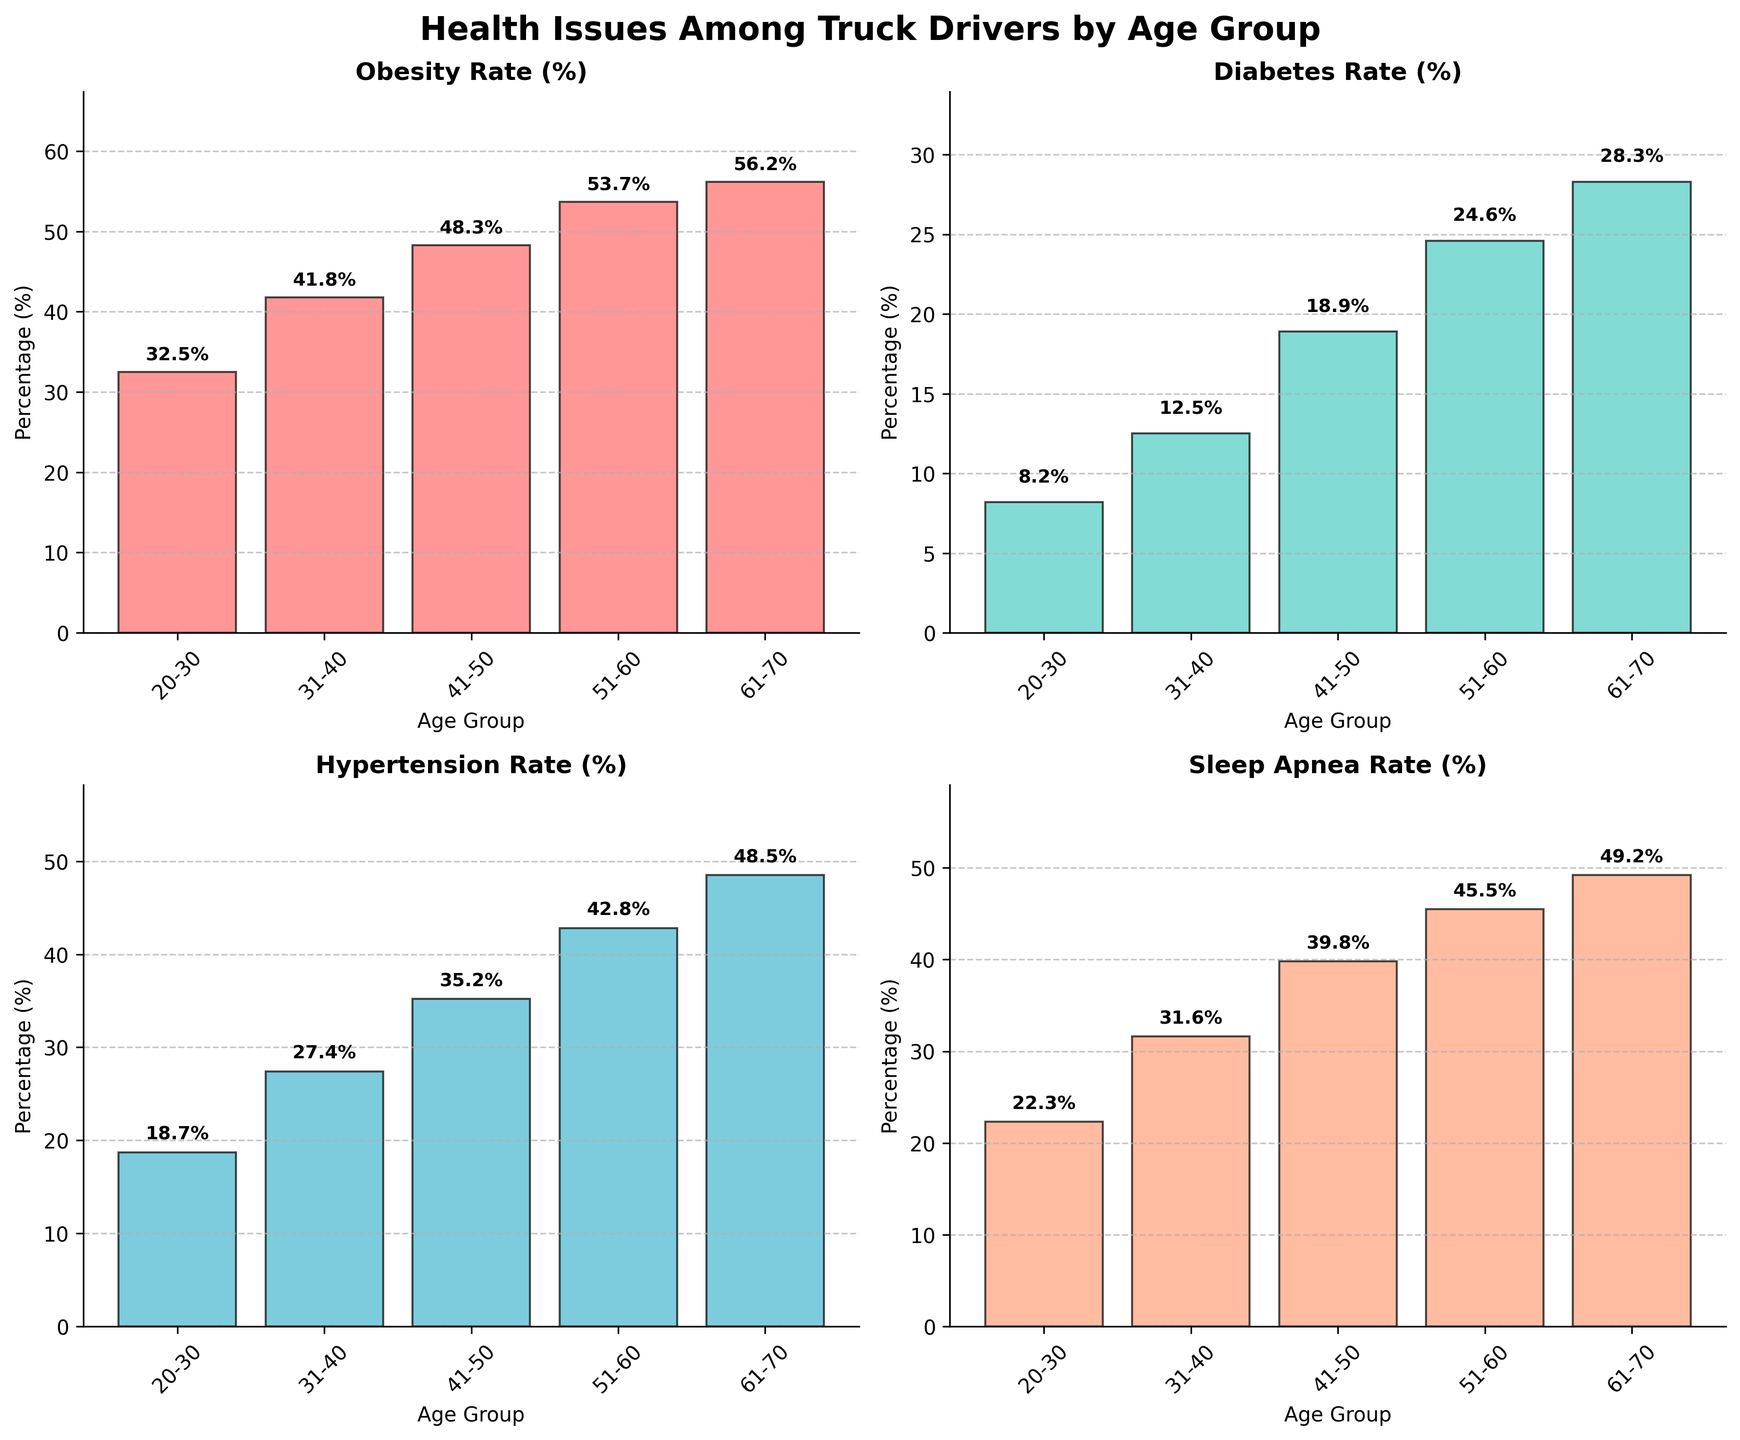What health issue has the highest prevalence rate in the 20-30 age group? The figure shows various health issues by age group. For the 20-30 age group, the highest bar represents the obesity rate at 32.5%.
Answer: Obesity Which age group has the highest rate of hypertension? By examining the bars in the Hypertension Rate subplot, the age group 61-70 has the highest bar at 48.5%.
Answer: 61-70 What is the difference in diabetes rate between the 31-40 and 51-60 age groups? The diabetes rate for 31-40 is 12.5%, and for 51-60, it is 24.6%. The difference is 24.6% - 12.5% = 12.1%.
Answer: 12.1% In which age group is the rate of sleep apnea more than double the rate of diabetes? Sleep apnea in the 61-70 age group is 49.2%, and diabetes is 28.3%. Since 49.2% is more than double 28.3%, the correct group is 61-70.
Answer: 61-70 What is the overall trend of obesity rates as age increases? The obesity rate increases progressively in each successive age group, from 32.5% in the 20-30 group to 56.2% in the 61-70 group.
Answer: Increasing Which health issue has the most significant increase in prevalence from the 41-50 age group to the 51-60 age group? From the plots, hypertension increases from 35.2% to 42.8%, a difference of 7.6%. This is higher than any other relative increase within the same age range for other health issues.
Answer: Hypertension What health issue shows a prevalence rate of approximately 31.6% for the 31-40 age group? By inspecting the figure, the sleep apnea rate is 31.6% for the 31-40 age group.
Answer: Sleep Apnea Which age group shows the smallest difference between the rates of obesity and hypertension? By comparing the rates for each age group, 31-40 age group shows obesity at 41.8% and hypertension at 27.4%. The difference is 41.8% - 27.4% = 14.4%, which is the smallest difference among all groups.
Answer: 31-40 What is the average obesity rate across all age groups? Sum the obesity rates for all groups (32.5% + 41.8% + 48.3% + 53.7% + 56.2%) = 232.5%. Divide by the number of groups (5) to get the average: 232.5% / 5 = 46.5%.
Answer: 46.5% What age group has the most consistently low rates across all health issues? The figure shows that the 20-30 age group has the lowest rates across all health issues compared to other age groups.
Answer: 20-30 